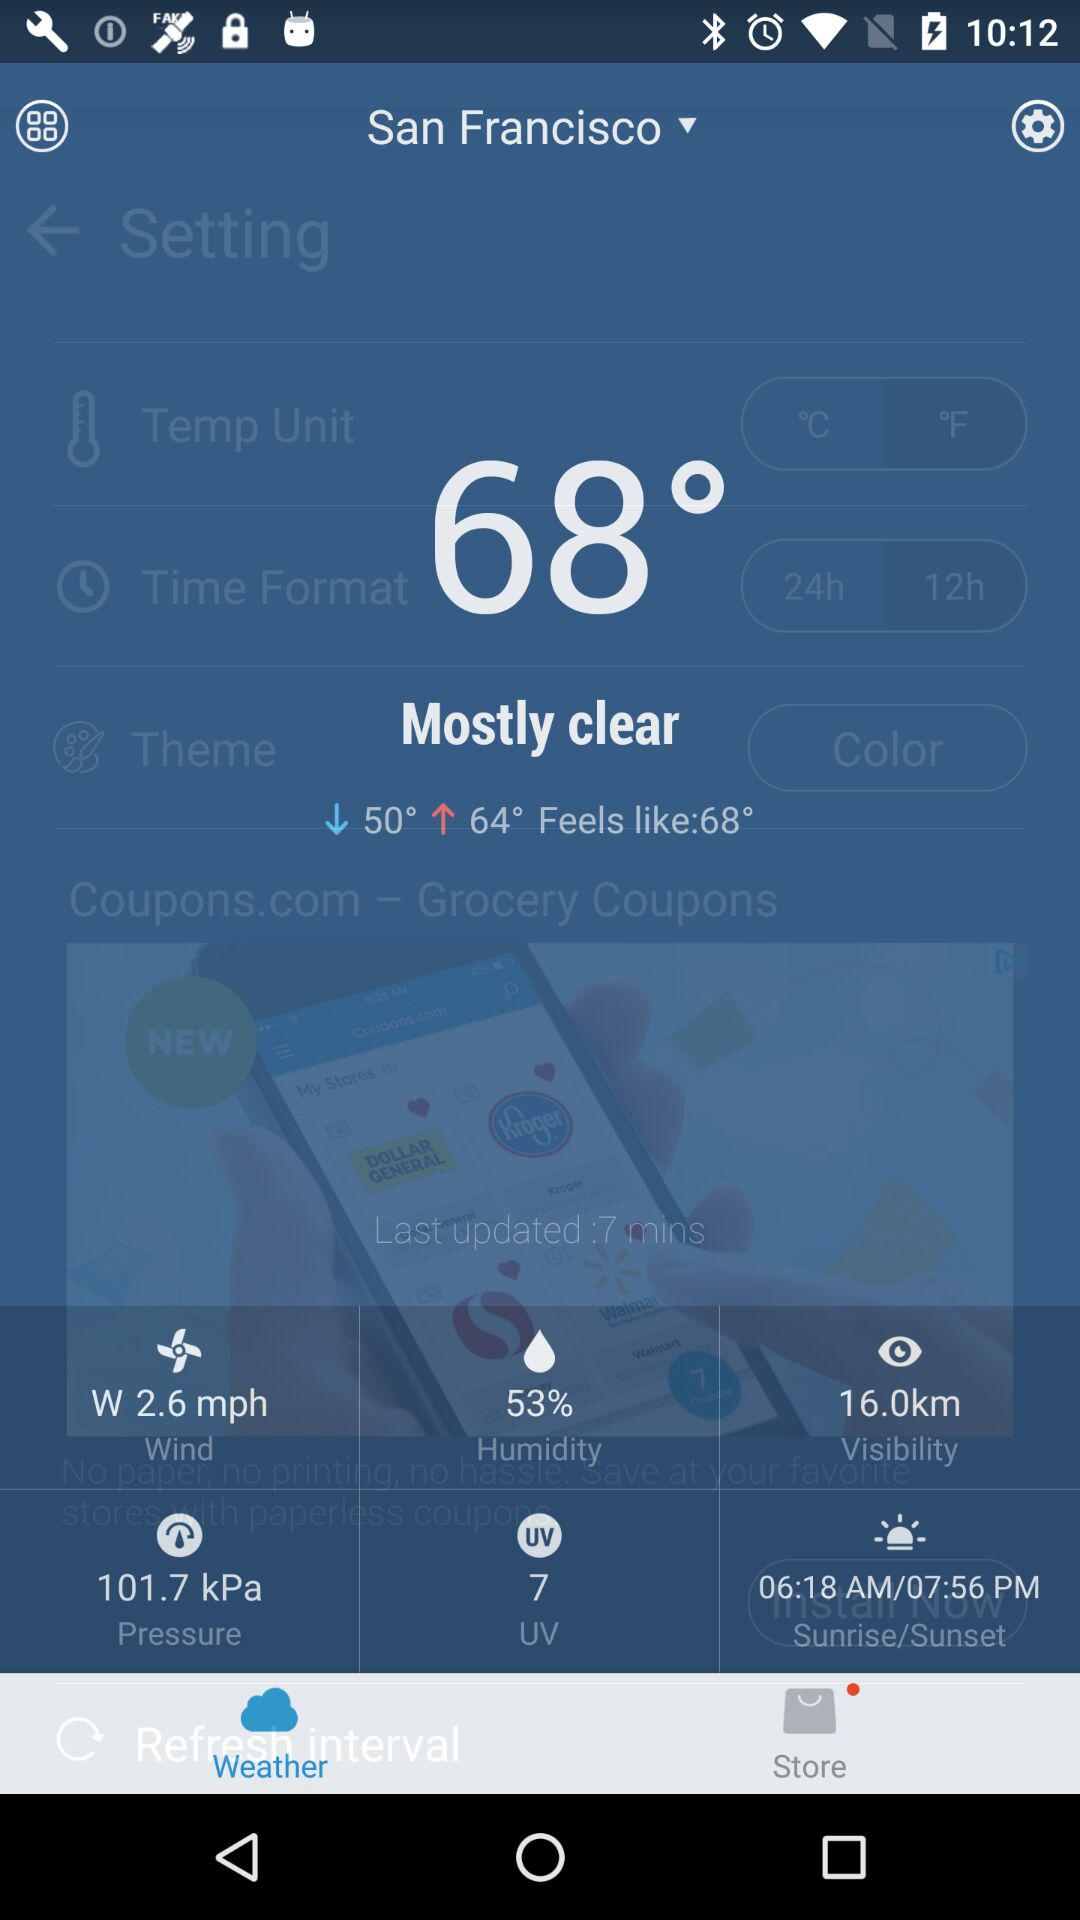What is the humidity percentage?
Answer the question using a single word or phrase. 53% 